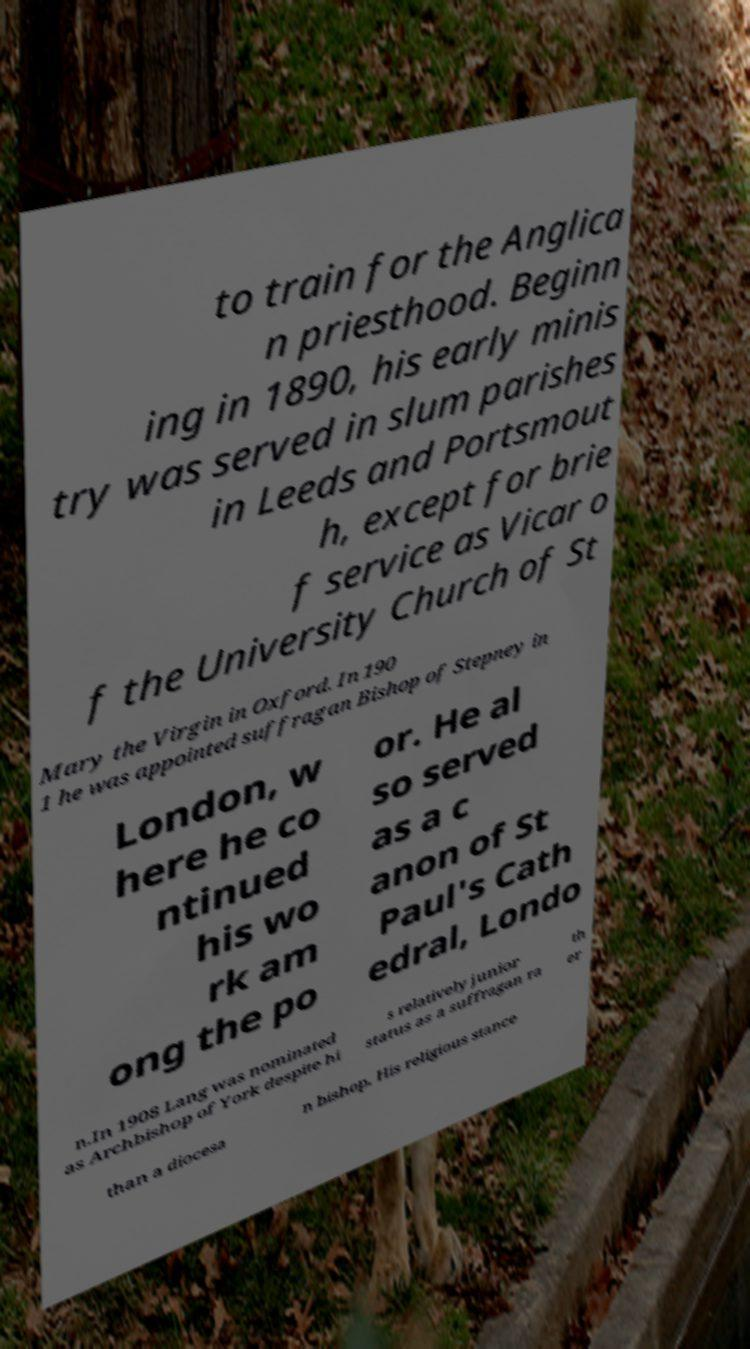Can you read and provide the text displayed in the image?This photo seems to have some interesting text. Can you extract and type it out for me? to train for the Anglica n priesthood. Beginn ing in 1890, his early minis try was served in slum parishes in Leeds and Portsmout h, except for brie f service as Vicar o f the University Church of St Mary the Virgin in Oxford. In 190 1 he was appointed suffragan Bishop of Stepney in London, w here he co ntinued his wo rk am ong the po or. He al so served as a c anon of St Paul's Cath edral, Londo n.In 1908 Lang was nominated as Archbishop of York despite hi s relatively junior status as a suffragan ra th er than a diocesa n bishop. His religious stance 